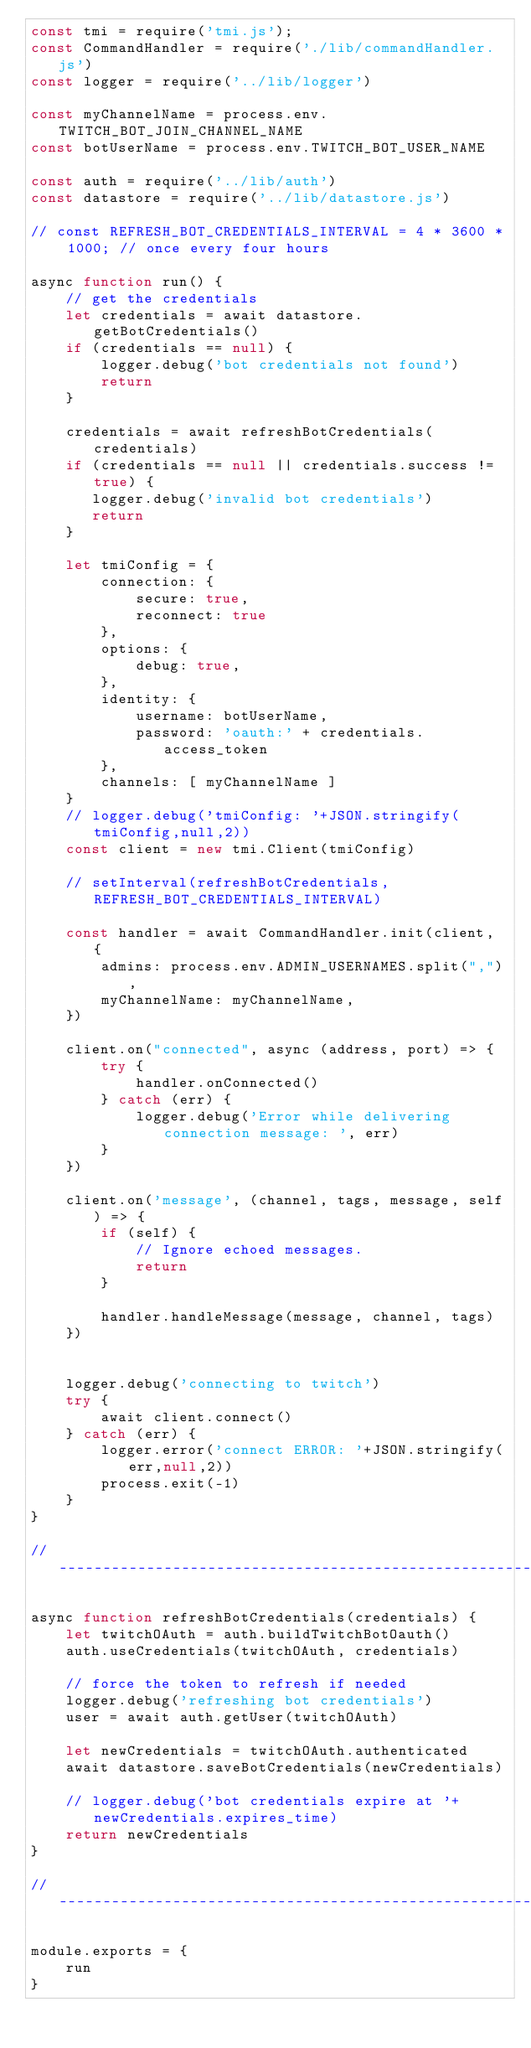Convert code to text. <code><loc_0><loc_0><loc_500><loc_500><_JavaScript_>const tmi = require('tmi.js');
const CommandHandler = require('./lib/commandHandler.js')
const logger = require('../lib/logger')

const myChannelName = process.env.TWITCH_BOT_JOIN_CHANNEL_NAME
const botUserName = process.env.TWITCH_BOT_USER_NAME

const auth = require('../lib/auth')
const datastore = require('../lib/datastore.js')

// const REFRESH_BOT_CREDENTIALS_INTERVAL = 4 * 3600 * 1000; // once every four hours

async function run() {
    // get the credentials
    let credentials = await datastore.getBotCredentials()
    if (credentials == null) {
        logger.debug('bot credentials not found')
        return
    }

    credentials = await refreshBotCredentials(credentials)
    if (credentials == null || credentials.success != true) {
       logger.debug('invalid bot credentials')
       return
    }

    let tmiConfig = {
        connection: {
            secure: true,
            reconnect: true
        },
        options: {
            debug: true,
        },
        identity: {
            username: botUserName,
            password: 'oauth:' + credentials.access_token
        },
        channels: [ myChannelName ]
    }
    // logger.debug('tmiConfig: '+JSON.stringify(tmiConfig,null,2))
    const client = new tmi.Client(tmiConfig)

    // setInterval(refreshBotCredentials, REFRESH_BOT_CREDENTIALS_INTERVAL)

    const handler = await CommandHandler.init(client, {
        admins: process.env.ADMIN_USERNAMES.split(","),
        myChannelName: myChannelName,
    })

    client.on("connected", async (address, port) => {
        try {
            handler.onConnected()
        } catch (err) {
            logger.debug('Error while delivering connection message: ', err)
        }
    })

    client.on('message', (channel, tags, message, self) => {
        if (self) {
            // Ignore echoed messages.
            return
        }

        handler.handleMessage(message, channel, tags)
    })


    logger.debug('connecting to twitch')
    try {
        await client.connect()
    } catch (err) {
        logger.error('connect ERROR: '+JSON.stringify(err,null,2))
        process.exit(-1)
    }
}

// ------------------------------------------------------------------------

async function refreshBotCredentials(credentials) {
    let twitchOAuth = auth.buildTwitchBotOauth()
    auth.useCredentials(twitchOAuth, credentials)

    // force the token to refresh if needed
    logger.debug('refreshing bot credentials')
    user = await auth.getUser(twitchOAuth)

    let newCredentials = twitchOAuth.authenticated
    await datastore.saveBotCredentials(newCredentials)

    // logger.debug('bot credentials expire at '+newCredentials.expires_time)
    return newCredentials
}

// ------------------------------------------------------------------------
    
module.exports = {
    run
}</code> 